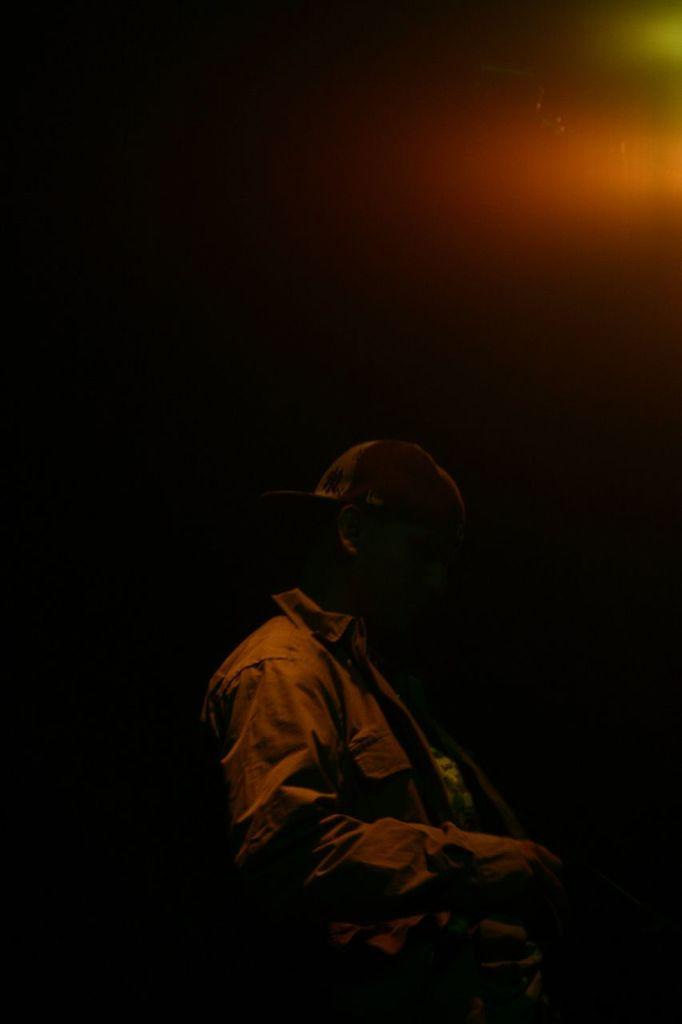What is the main subject of the image? The main subject of the image is a man. What is the man wearing in the image? The man is wearing a black jacket in the image. How would you describe the lighting in the image? The image is dark. How many oranges can be seen in the man's hands in the image? There are no oranges present in the image. What type of vehicle is the fireman driving in the image? There is no fireman or vehicle present in the image. 